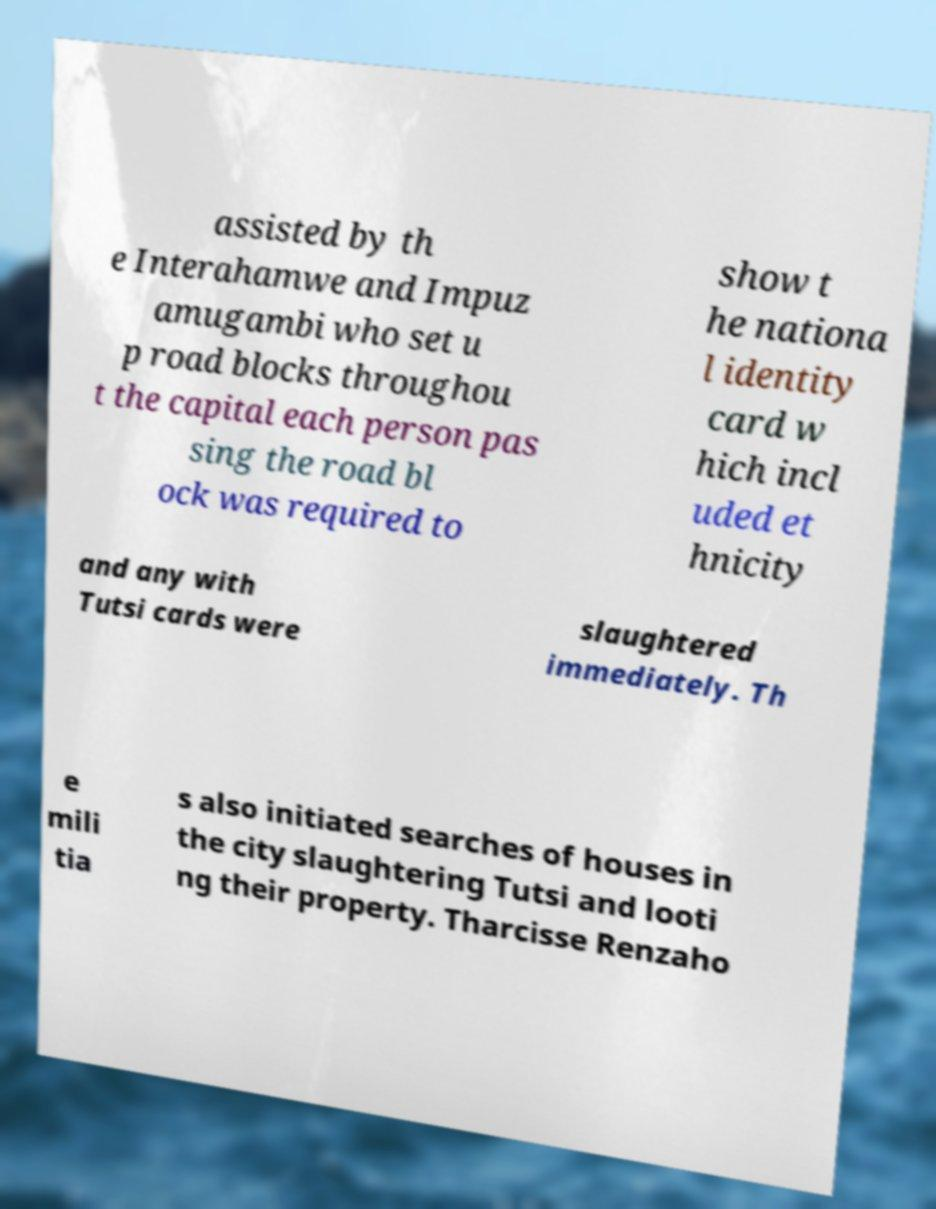Can you read and provide the text displayed in the image?This photo seems to have some interesting text. Can you extract and type it out for me? assisted by th e Interahamwe and Impuz amugambi who set u p road blocks throughou t the capital each person pas sing the road bl ock was required to show t he nationa l identity card w hich incl uded et hnicity and any with Tutsi cards were slaughtered immediately. Th e mili tia s also initiated searches of houses in the city slaughtering Tutsi and looti ng their property. Tharcisse Renzaho 